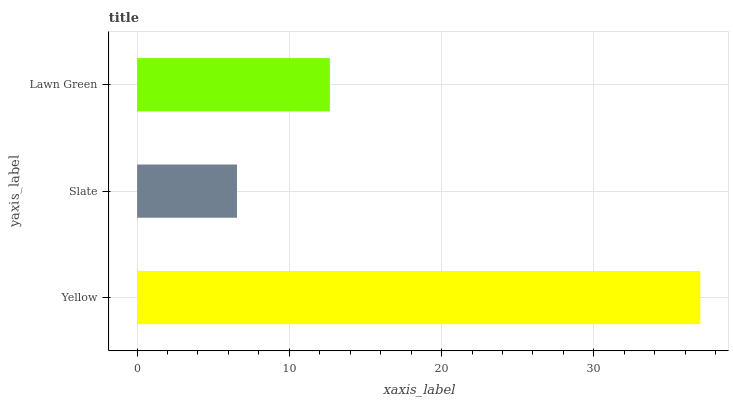Is Slate the minimum?
Answer yes or no. Yes. Is Yellow the maximum?
Answer yes or no. Yes. Is Lawn Green the minimum?
Answer yes or no. No. Is Lawn Green the maximum?
Answer yes or no. No. Is Lawn Green greater than Slate?
Answer yes or no. Yes. Is Slate less than Lawn Green?
Answer yes or no. Yes. Is Slate greater than Lawn Green?
Answer yes or no. No. Is Lawn Green less than Slate?
Answer yes or no. No. Is Lawn Green the high median?
Answer yes or no. Yes. Is Lawn Green the low median?
Answer yes or no. Yes. Is Yellow the high median?
Answer yes or no. No. Is Yellow the low median?
Answer yes or no. No. 